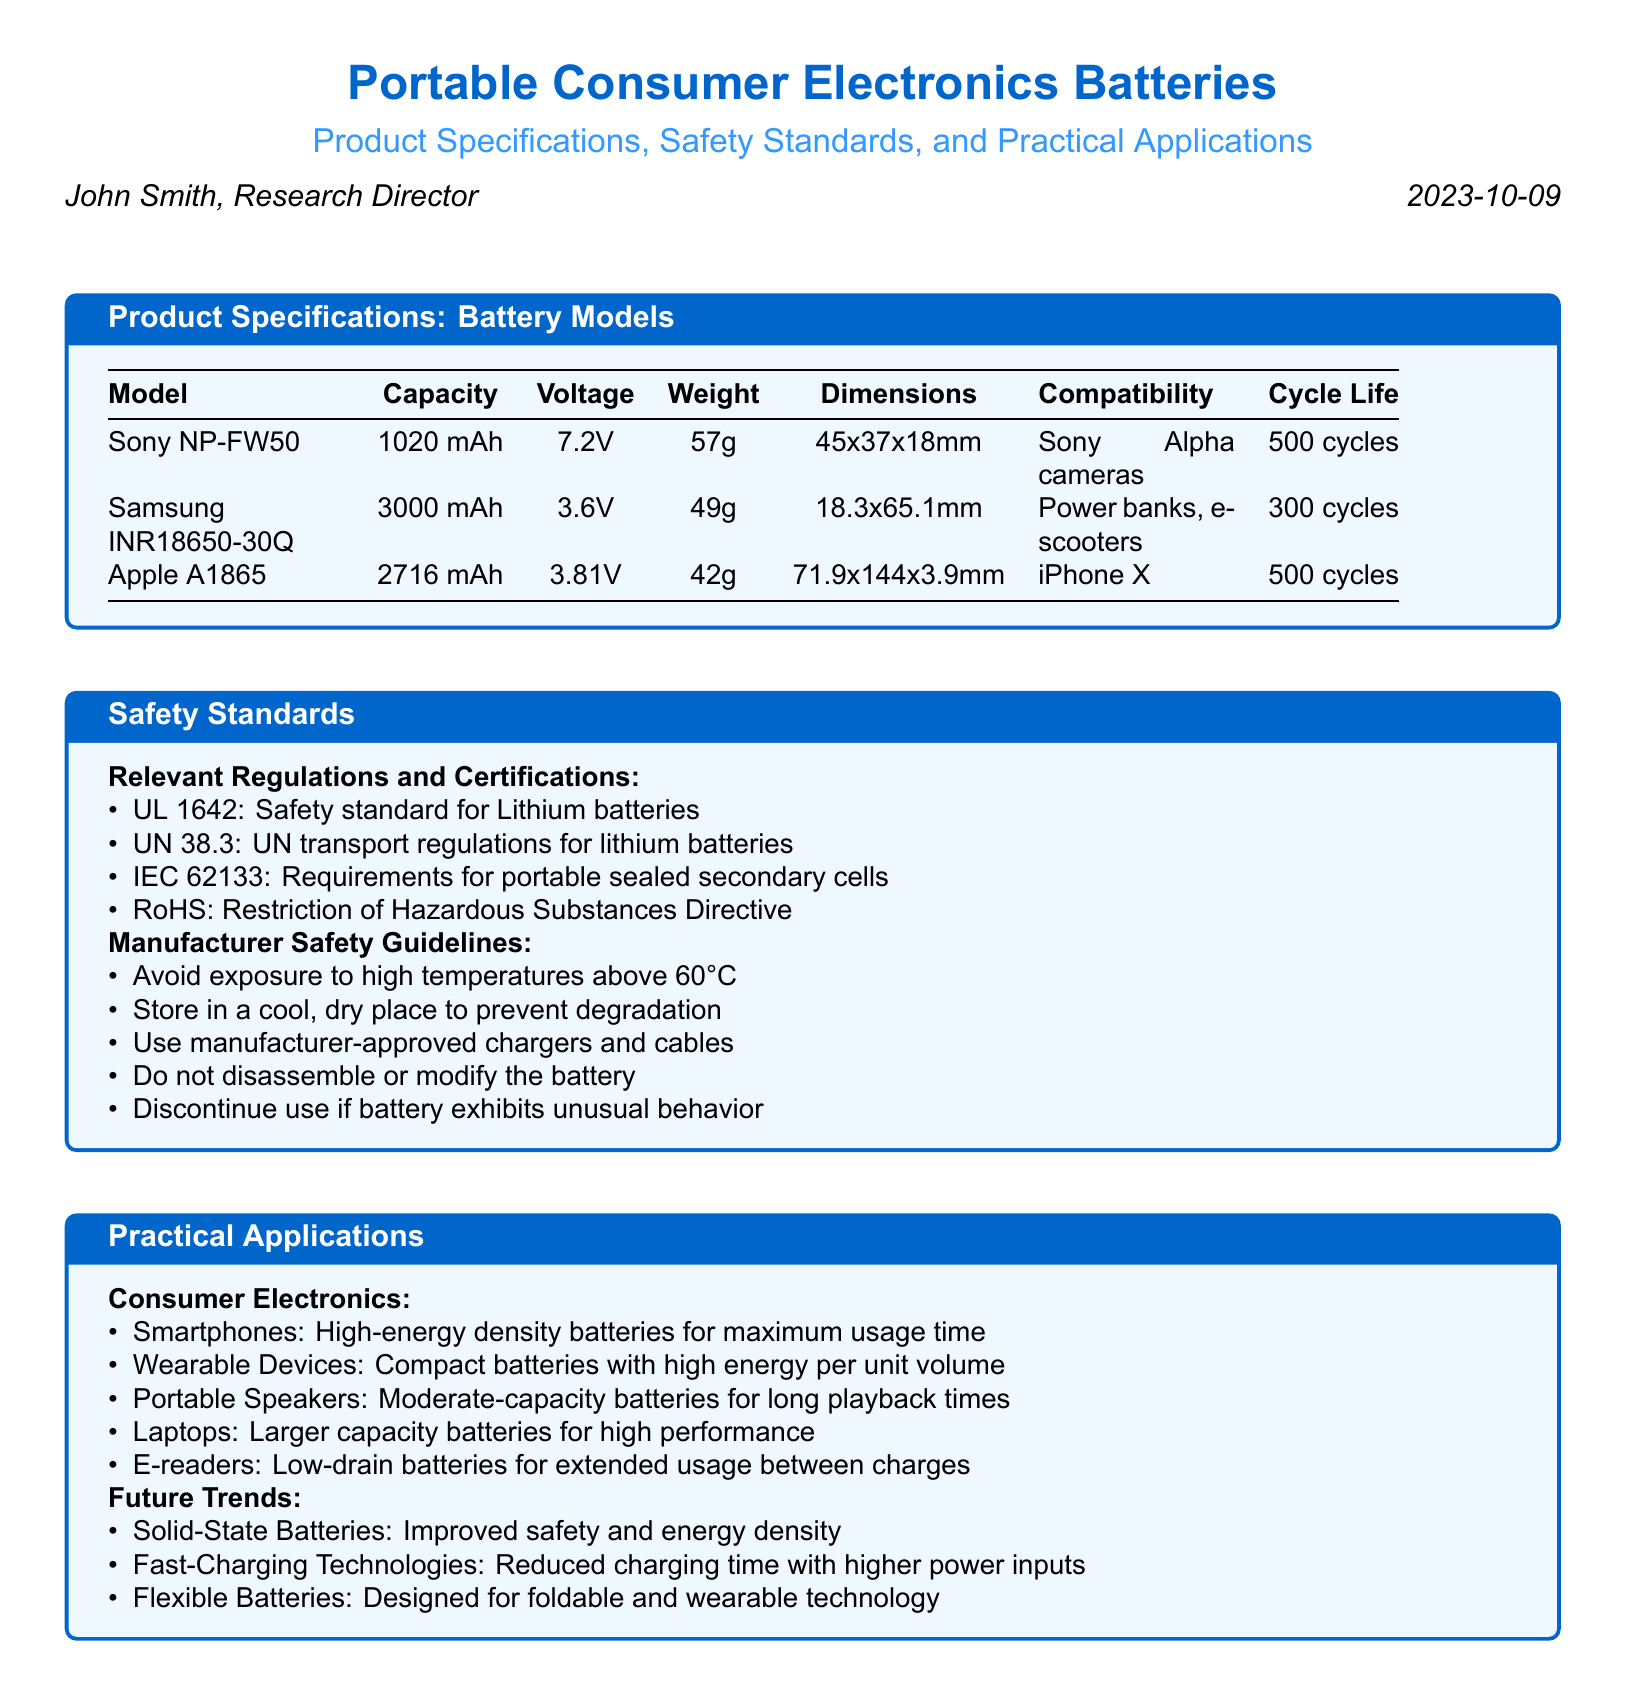what is the capacity of the Sony NP-FW50? The capacity of the Sony NP-FW50 is provided in the product specifications table.
Answer: 1020 mAh what type of devices is the Samsung INR18650-30Q compatible with? The compatibility of the Samsung INR18650-30Q is listed in the product specifications.
Answer: Power banks, e-scooters how many cycles does the Apple A1865 battery last? The cycle life of the Apple A1865 is noted in the product specifications.
Answer: 500 cycles which safety standard addresses lithium battery safety? The relevant regulations listed under safety standards indicate the specific safety standard for lithium batteries.
Answer: UL 1642 what is the maximum temperature to avoid for battery safety? The manufacturer safety guidelines specify a temperature limit for battery safety.
Answer: 60°C what is a practical application of batteries in smartphones? The practical applications mention the role of batteries in smartphones.
Answer: High-energy density batteries for maximum usage time what future trend involves improved safety and energy density? One future trend listed in the practical applications relates to battery technology improvements.
Answer: Solid-State Batteries what is the voltage of the Samsung INR18650-30Q? The voltage for the Samsung INR18650-30Q is detailed in the product specifications.
Answer: 3.6V which regulation pertains to the transport of lithium batteries? The safety standards section mentions a regulation regarding the transport of lithium batteries.
Answer: UN 38.3 